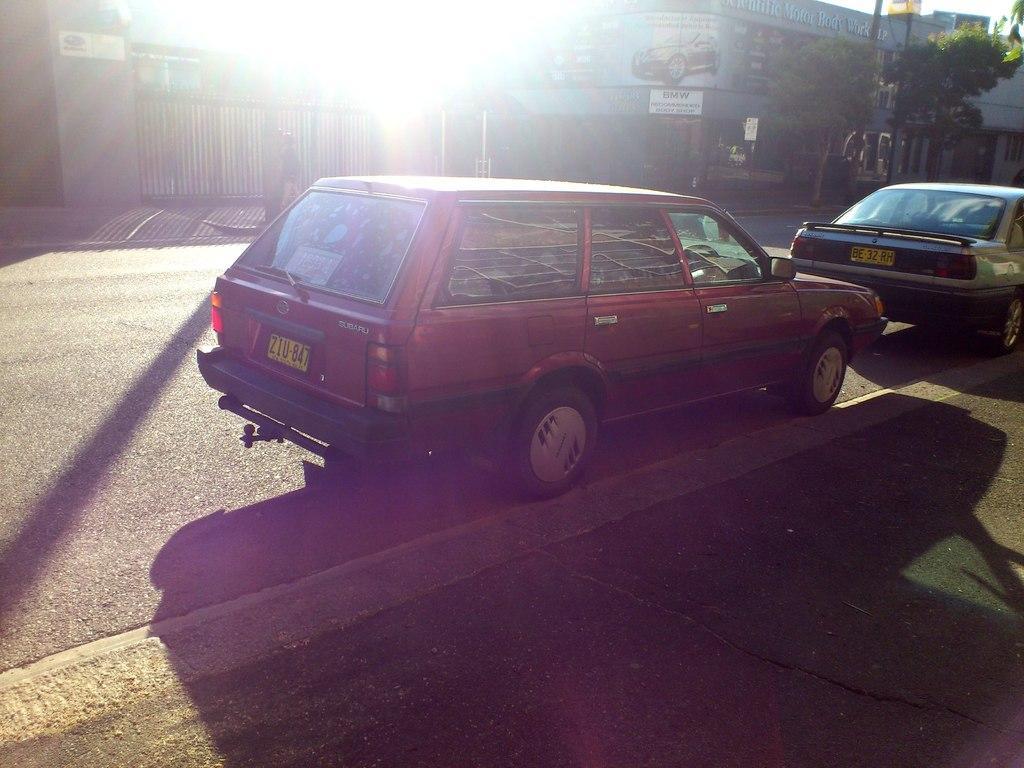Could you give a brief overview of what you see in this image? In this image I can see few buildings, few stairs, trees, boards, gate and few vehicles on the road. 